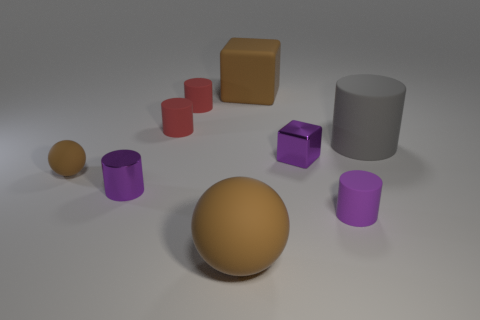Subtract 2 cylinders. How many cylinders are left? 3 Subtract all red cylinders. How many cylinders are left? 3 Subtract all tiny metallic cylinders. How many cylinders are left? 4 Add 1 large shiny balls. How many objects exist? 10 Subtract all blue cylinders. Subtract all green balls. How many cylinders are left? 5 Subtract all spheres. How many objects are left? 7 Add 1 green shiny cubes. How many green shiny cubes exist? 1 Subtract 1 brown cubes. How many objects are left? 8 Subtract all small brown objects. Subtract all big spheres. How many objects are left? 7 Add 9 small brown objects. How many small brown objects are left? 10 